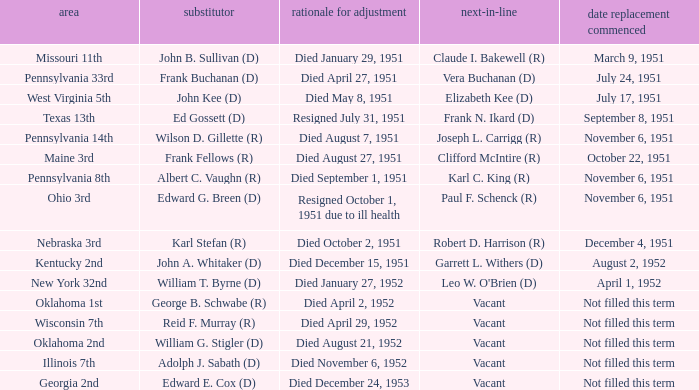How many vacators were in the Pennsylvania 33rd district? 1.0. 